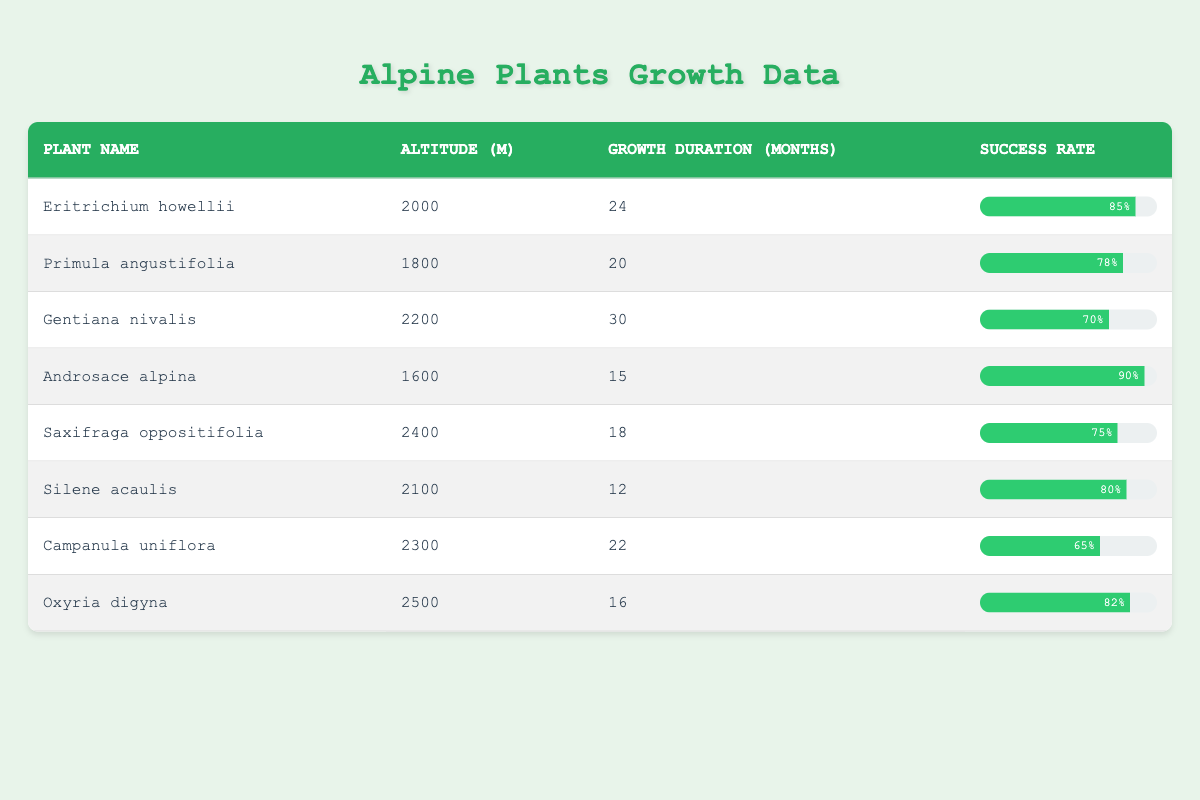What is the success rate of Eritrichium howellii? The success rate for Eritrichium howellii is listed in the table under the "Success Rate" column, which shows 85%.
Answer: 85% Which plant has the longest growth duration? By examining the "Growth Duration" column, the plant with the longest growth duration is Gentiana nivalis with 30 months.
Answer: 30 months What is the average growth duration of all the plants listed? To find the average growth duration, sum up all growth durations (24 + 20 + 30 + 15 + 18 + 12 + 22 + 16 = 147) and divide by the number of plants (8). This gives an average of 147 / 8 = 18.375 months.
Answer: 18.375 months Is it true that every plant listed has a success rate above 60%? By checking the "Success Rate" column for each plant, all show rates above 60%. Therefore, the statement is true.
Answer: Yes Which plant has the highest success rate among those with a growth duration of 20 months or less? The plants with a growth duration of 20 months or less include Androsace alpina (15 months, 90%) and Silene acaulis (12 months, 80%). Comparing the two, Androsace alpina has the highest success rate at 90%.
Answer: Androsace alpina How does the success rate of plants at altitudes over 2200 meters compare to those below that altitude? Plants at altitudes over 2200 meters are Gentiana nivalis (70%), Campanula uniflora (65%), and Oxyria digyna (82%). The average success rate for these is (70 + 65 + 82) / 3 = 72.33%. For plants below 2200 meters, they are Eritrichium howellii (85%), Primula angustifolia (78%), Androsace alpina (90%), Saxifraga oppositifolia (75%), and Silene acaulis (80%), which gives an average of (85 + 78 + 90 + 75 + 80) / 5 = 81.6%. So plants below 2200 meters have a higher average success rate.
Answer: Plants below 2200 meters have a higher average success rate Which plant has a shorter growth duration but a higher success rate than Saxifraga oppositifolia? Saxifraga oppositifolia has a growth duration of 18 months and a success rate of 75%. Among plants with shorter growth durations, Silene acaulis (12 months, 80%) qualifies as a plant that meets both criteria.
Answer: Silene acaulis What success rate should I expect from planting Gentiana nivalis? The success rate for Gentiana nivalis is directly available in the table, which shows it is 70%.
Answer: 70% 